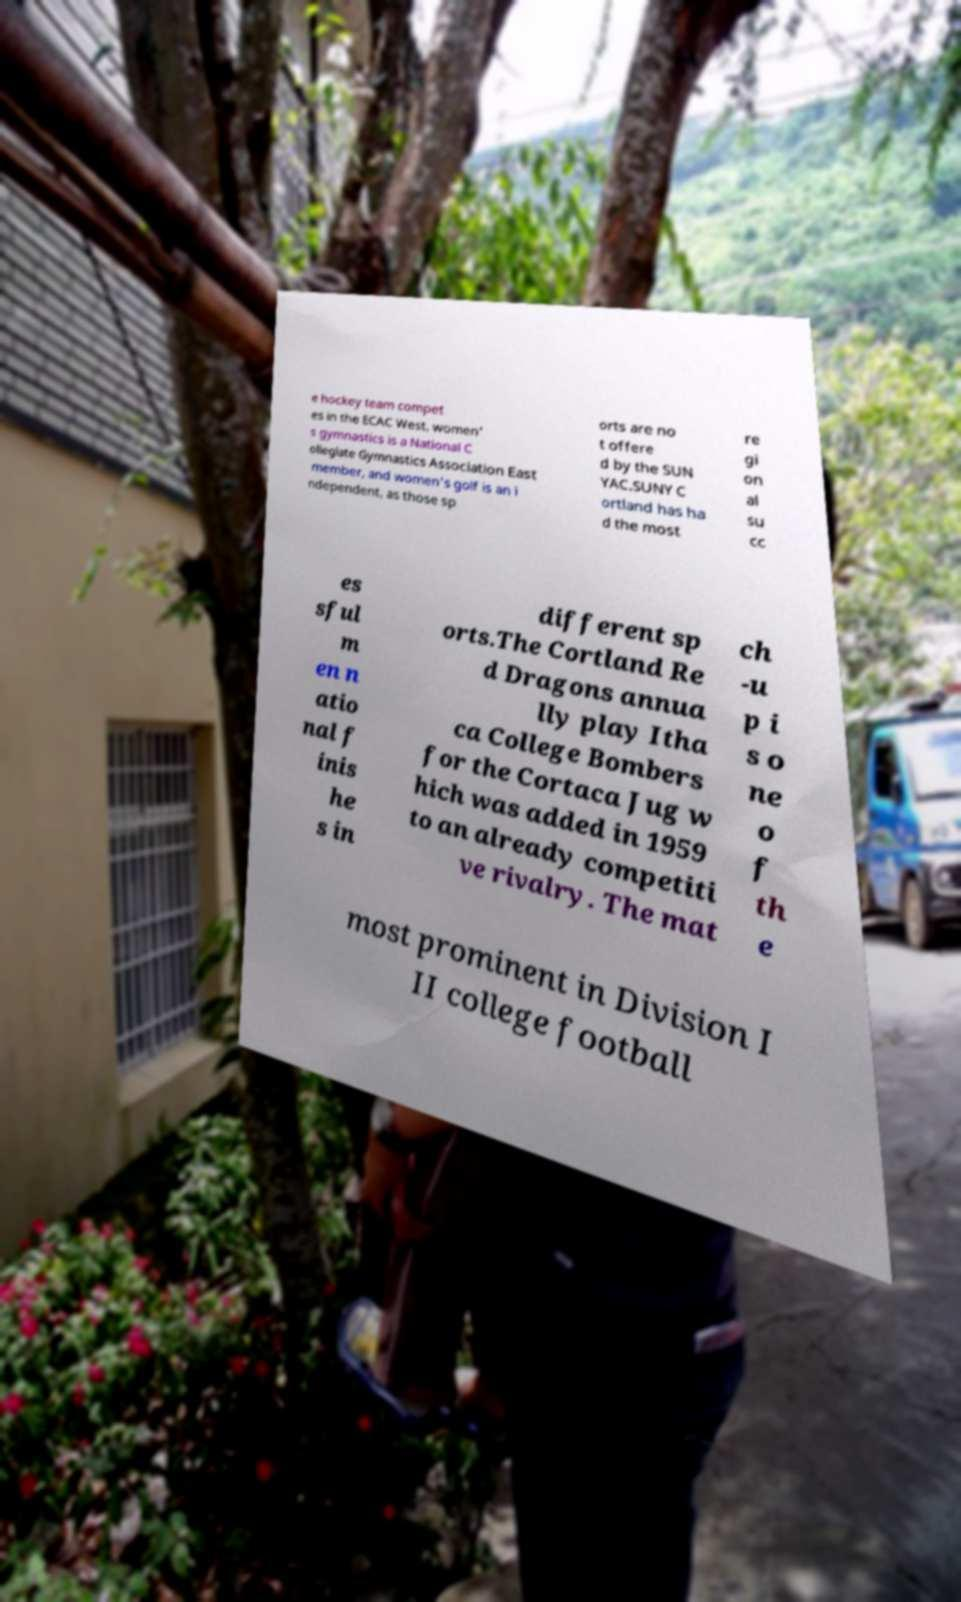Can you accurately transcribe the text from the provided image for me? e hockey team compet es in the ECAC West, women' s gymnastics is a National C ollegiate Gymnastics Association East member, and women's golf is an i ndependent, as those sp orts are no t offere d by the SUN YAC.SUNY C ortland has ha d the most re gi on al su cc es sful m en n atio nal f inis he s in different sp orts.The Cortland Re d Dragons annua lly play Itha ca College Bombers for the Cortaca Jug w hich was added in 1959 to an already competiti ve rivalry. The mat ch -u p i s o ne o f th e most prominent in Division I II college football 